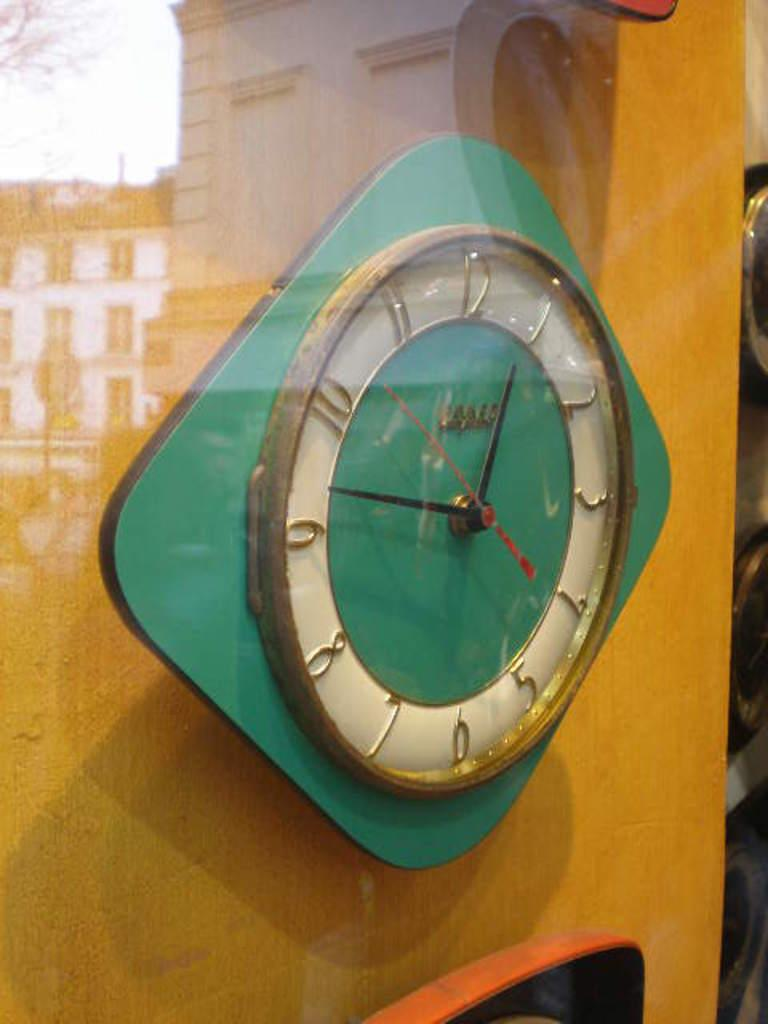<image>
Present a compact description of the photo's key features. Green and white clock with the hands on the numbers 9 and 1. 